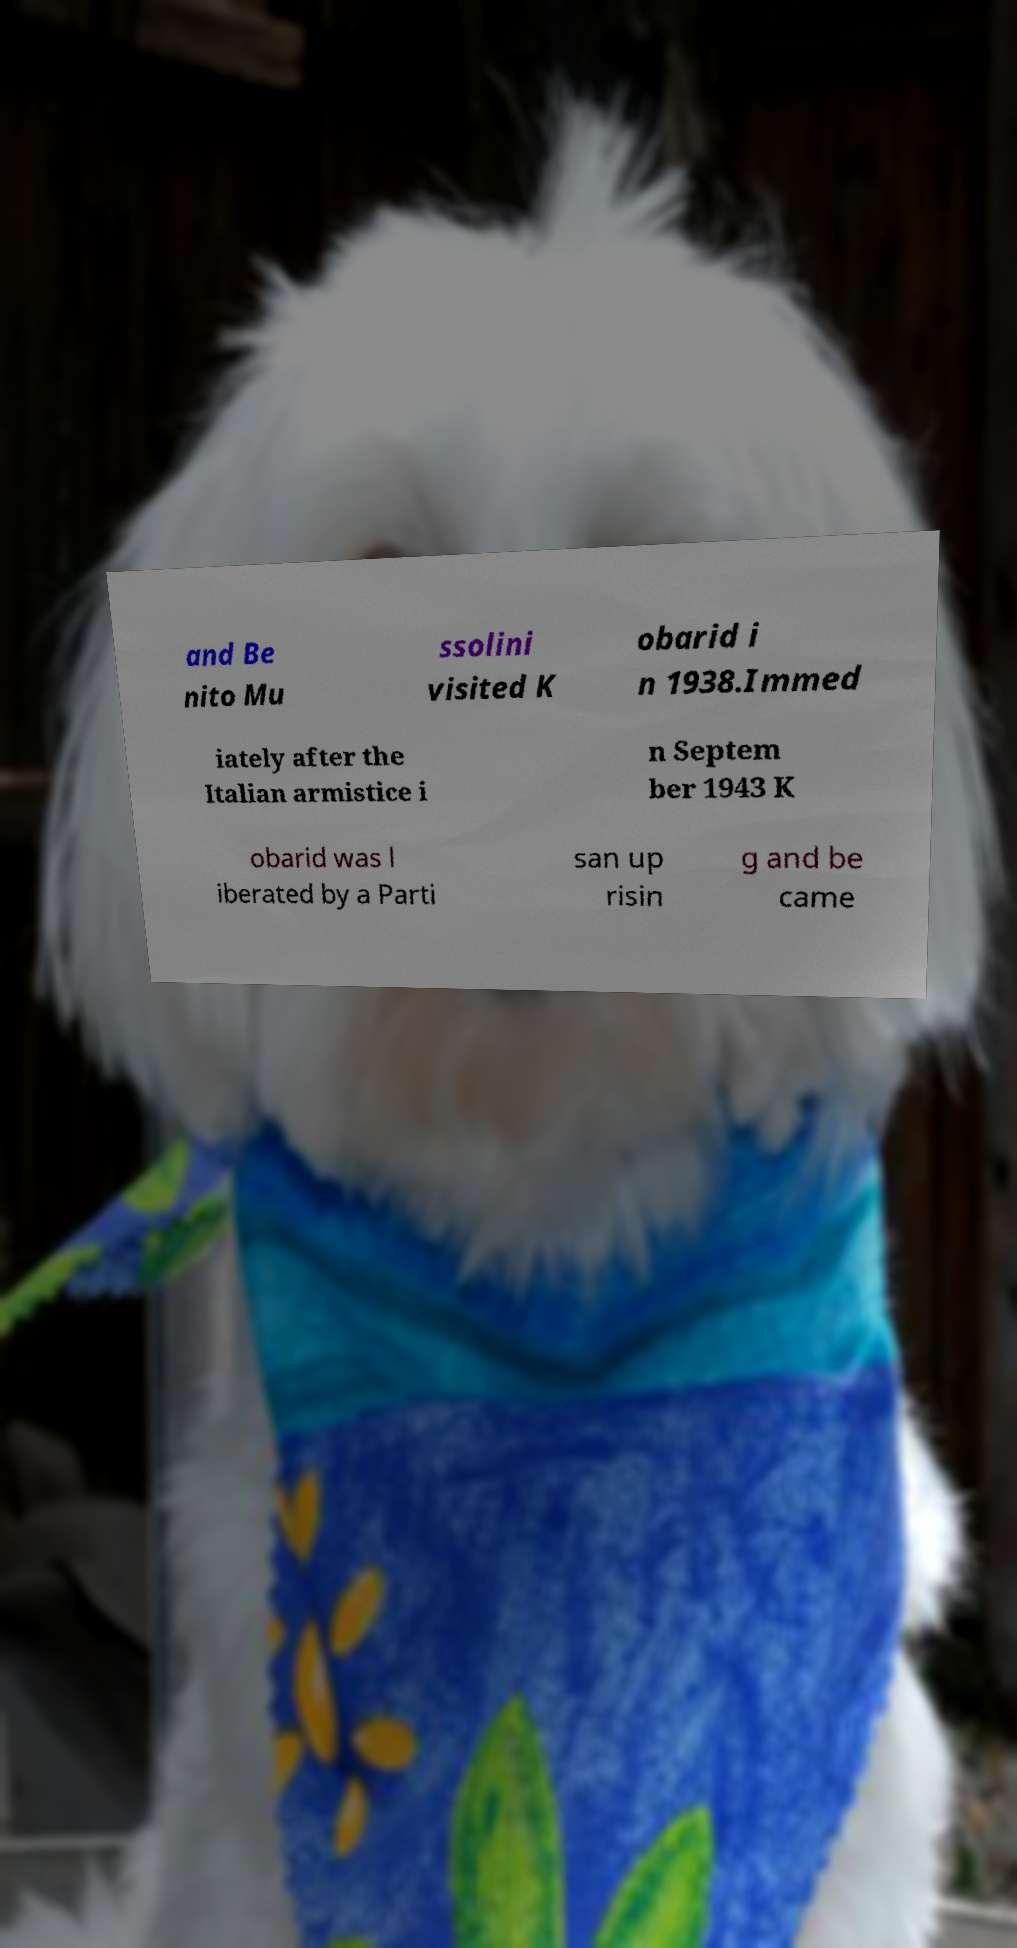What messages or text are displayed in this image? I need them in a readable, typed format. and Be nito Mu ssolini visited K obarid i n 1938.Immed iately after the Italian armistice i n Septem ber 1943 K obarid was l iberated by a Parti san up risin g and be came 